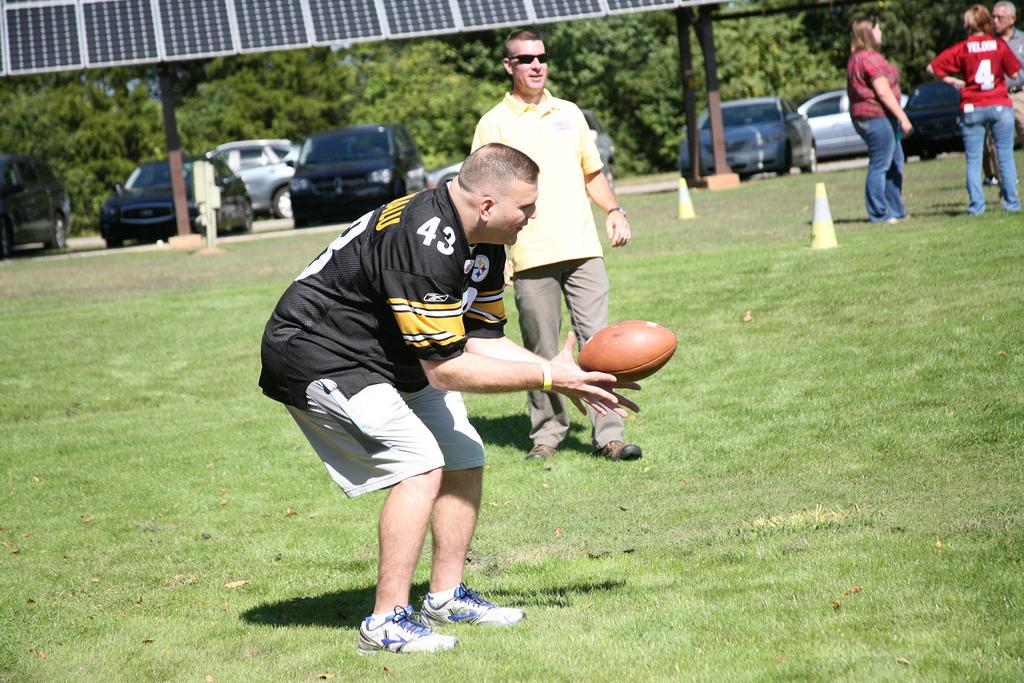What number is on his jersey?
Give a very brief answer. 43. 